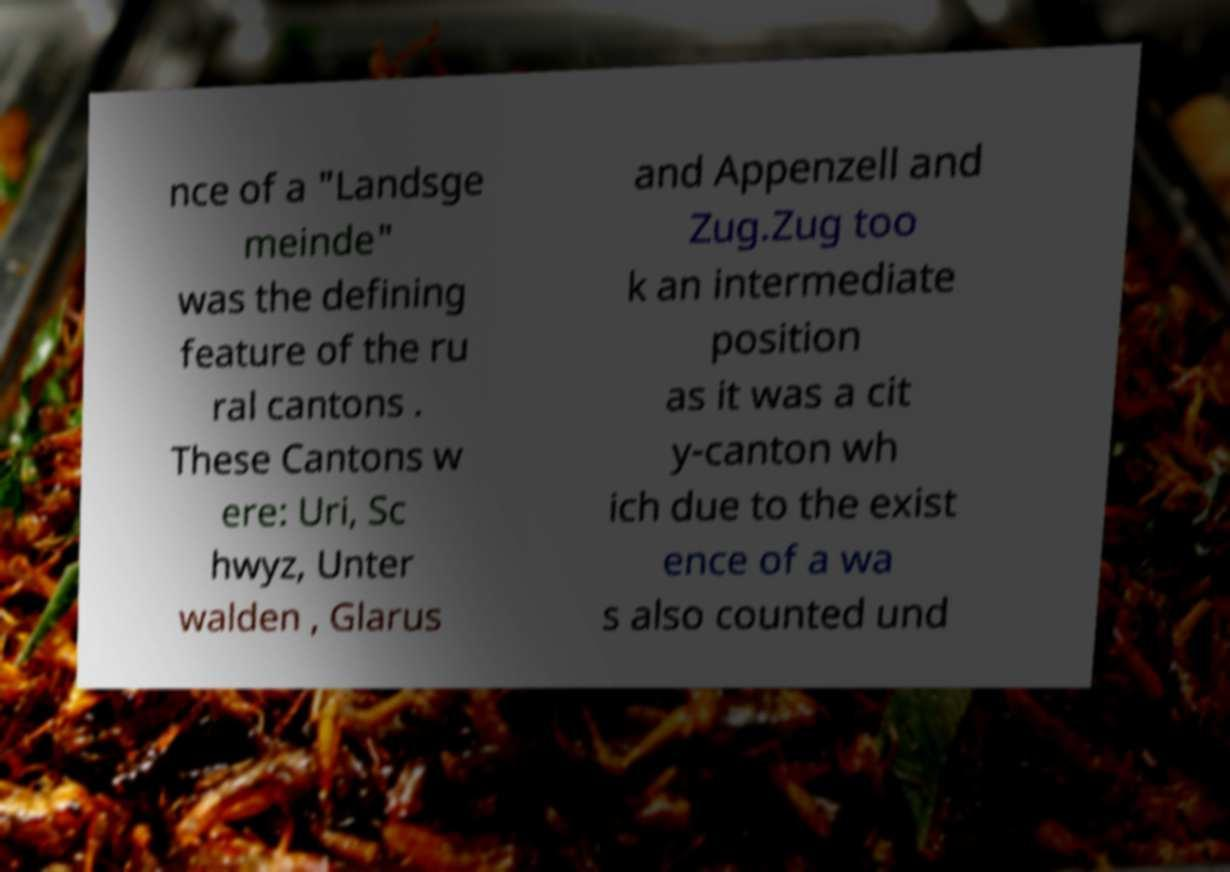There's text embedded in this image that I need extracted. Can you transcribe it verbatim? nce of a "Landsge meinde" was the defining feature of the ru ral cantons . These Cantons w ere: Uri, Sc hwyz, Unter walden , Glarus and Appenzell and Zug.Zug too k an intermediate position as it was a cit y-canton wh ich due to the exist ence of a wa s also counted und 